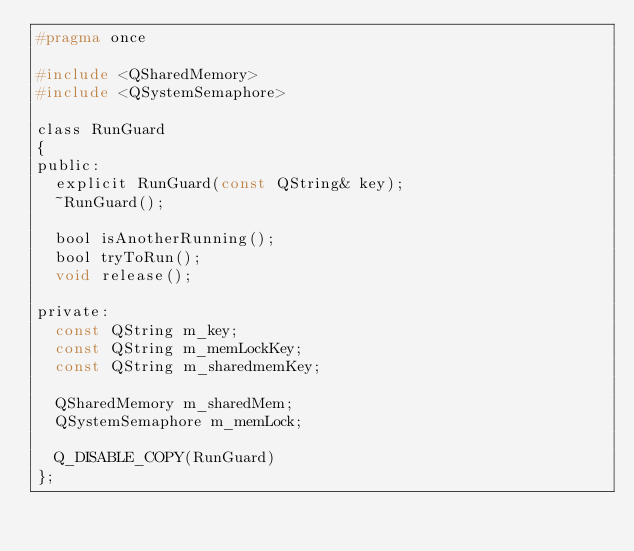<code> <loc_0><loc_0><loc_500><loc_500><_C_>#pragma once

#include <QSharedMemory>
#include <QSystemSemaphore>

class RunGuard
{
public:
  explicit RunGuard(const QString& key);
  ~RunGuard();

  bool isAnotherRunning();
  bool tryToRun();
  void release();

private:
  const QString m_key;
  const QString m_memLockKey;
  const QString m_sharedmemKey;

  QSharedMemory m_sharedMem;
  QSystemSemaphore m_memLock;

  Q_DISABLE_COPY(RunGuard)
};
</code> 